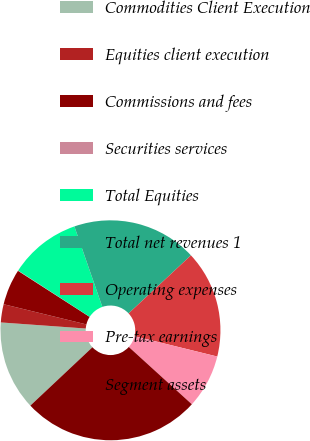Convert chart. <chart><loc_0><loc_0><loc_500><loc_500><pie_chart><fcel>Commodities Client Execution<fcel>Equities client execution<fcel>Commissions and fees<fcel>Securities services<fcel>Total Equities<fcel>Total net revenues 1<fcel>Operating expenses<fcel>Pre-tax earnings<fcel>Segment assets<nl><fcel>13.15%<fcel>2.67%<fcel>5.29%<fcel>0.05%<fcel>10.53%<fcel>18.39%<fcel>15.77%<fcel>7.91%<fcel>26.25%<nl></chart> 